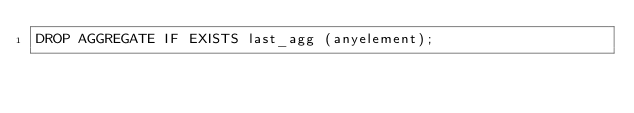Convert code to text. <code><loc_0><loc_0><loc_500><loc_500><_SQL_>DROP AGGREGATE IF EXISTS last_agg (anyelement);
</code> 